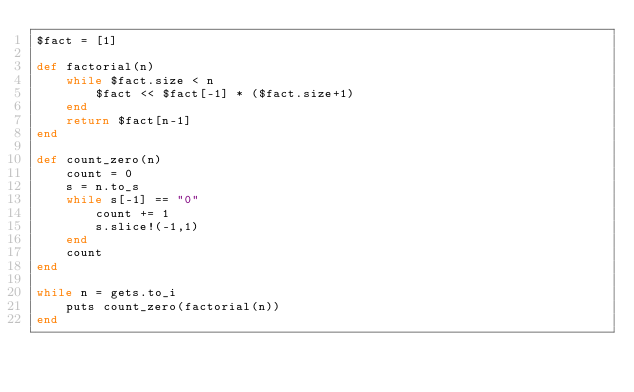Convert code to text. <code><loc_0><loc_0><loc_500><loc_500><_Ruby_>$fact = [1]

def factorial(n)
	while $fact.size < n
		$fact << $fact[-1] * ($fact.size+1)
	end
	return $fact[n-1]
end

def count_zero(n)
	count = 0
	s = n.to_s
	while s[-1] == "0"
		count += 1
		s.slice!(-1,1)
	end
	count
end

while n = gets.to_i
	puts count_zero(factorial(n)) 
end</code> 